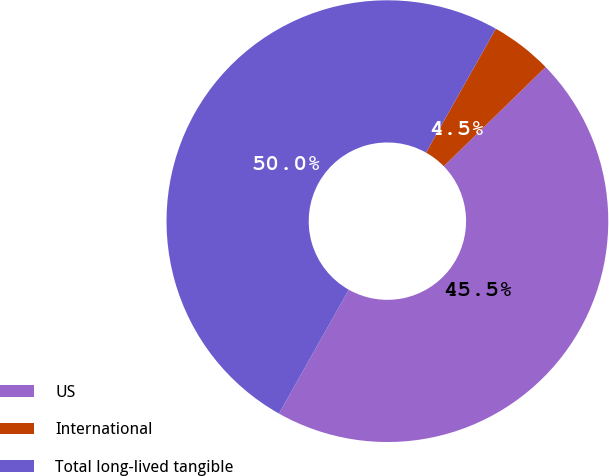Convert chart to OTSL. <chart><loc_0><loc_0><loc_500><loc_500><pie_chart><fcel>US<fcel>International<fcel>Total long-lived tangible<nl><fcel>45.46%<fcel>4.54%<fcel>50.0%<nl></chart> 